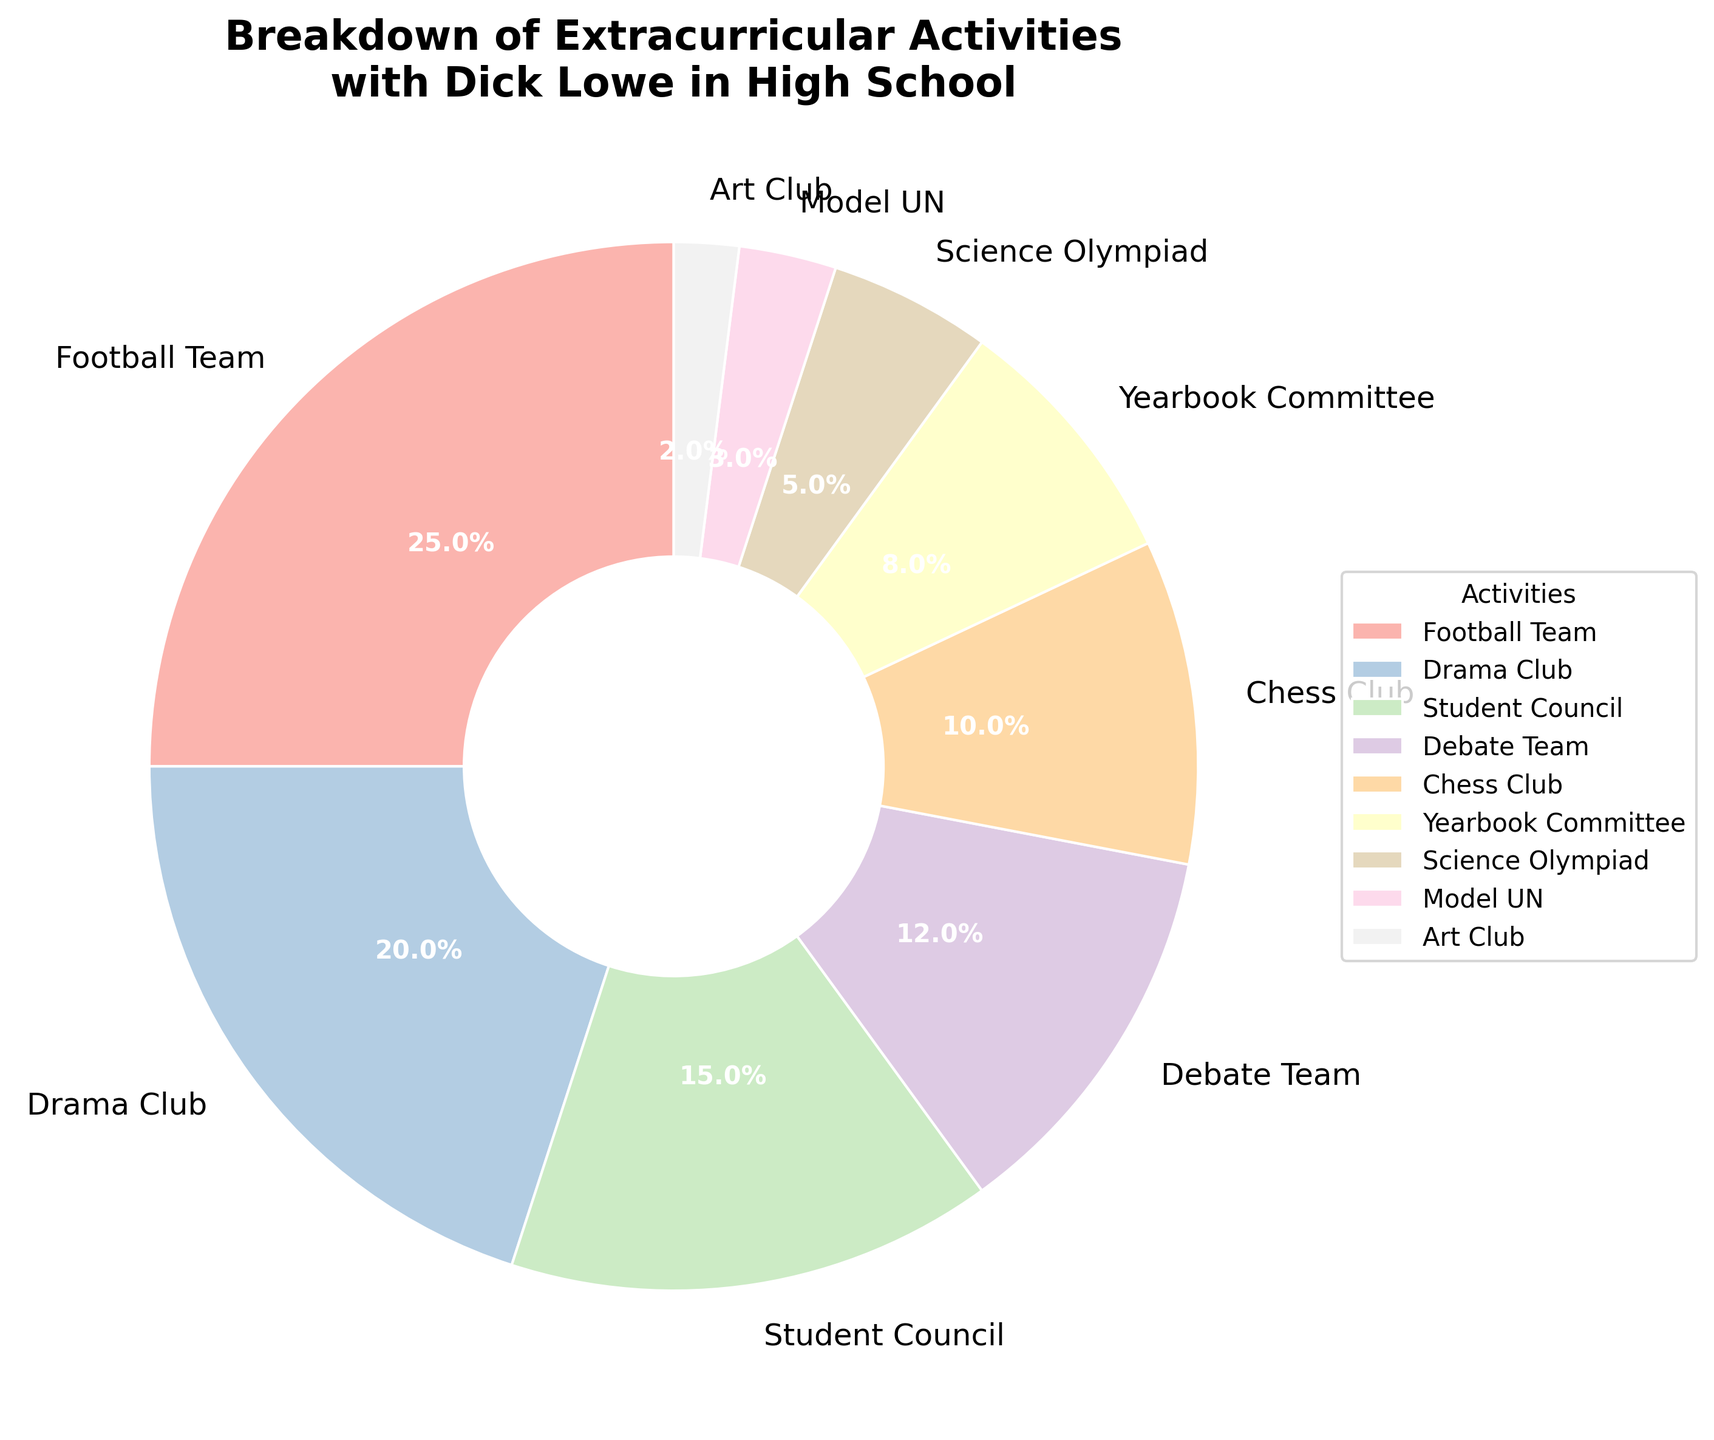What’s the total percentage of participation in Debate Team and Science Olympiad combined? To find the combined percentage, sum up the percentages for the Debate Team (12%) and Science Olympiad (5%). 12% + 5% = 17%
Answer: 17% Which extracurricular activity had the highest participation rate? Look at the pie chart and identify the largest slice. The Football Team slice is the largest at 25%
Answer: Football Team How much more participation did the Drama Club have compared to the Yearbook Committee? Determine the percentage for both activities: Drama Club (20%) and Yearbook Committee (8%). Subtract the Yearbook Committee’s percentage from the Drama Club’s percentage: 20% - 8% = 12%
Answer: 12% Is the percentage for Chess Club greater than that for Model UN? Compare the percentages for the Chess Club (10%) and Model UN (3%). 10% > 3%
Answer: Yes What is the total percentage for all clubs whose participation rate is less than 10%? Sum the percentages of all activities that are below 10%: Yearbook Committee (8%), Science Olympiad (5%), Model UN (3%), Art Club (2%). 8% + 5% + 3% + 2% = 18%
Answer: 18% Which activity has a smaller percentage than the Debate Team but larger than the Chess Club? Identify the activities with percentages between Debate Team (12%) and Chess Club (10%): No activities fall strictly between these percentages as the next highest (Student Council) is at 15%
Answer: None What is the difference in participation percentage between the Football Team and the Chess Club? Subtract the participation percentage of the Chess Club (10%) from that of the Football Team (25%): 25% - 10% = 15%
Answer: 15% What’s the sum of the percentages of the three activities with the lowest participation? Identify the three activities with the smallest percentages: Art Club (2%), Model UN (3%), and Science Olympiad (5%). Sum these percentages: 2% + 3% + 5% = 10%
Answer: 10% Which activity group has the closest participation rates to each other, excluding another activity with more than double its percentage? Compare the given percentages: Debate Team (12%), Chess Club (10%). Difference = 2%. No activity with more than double, hence this is the closest pair
Answer: Debate Team and Chess Club 